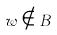Convert formula to latex. <formula><loc_0><loc_0><loc_500><loc_500>w \notin B</formula> 